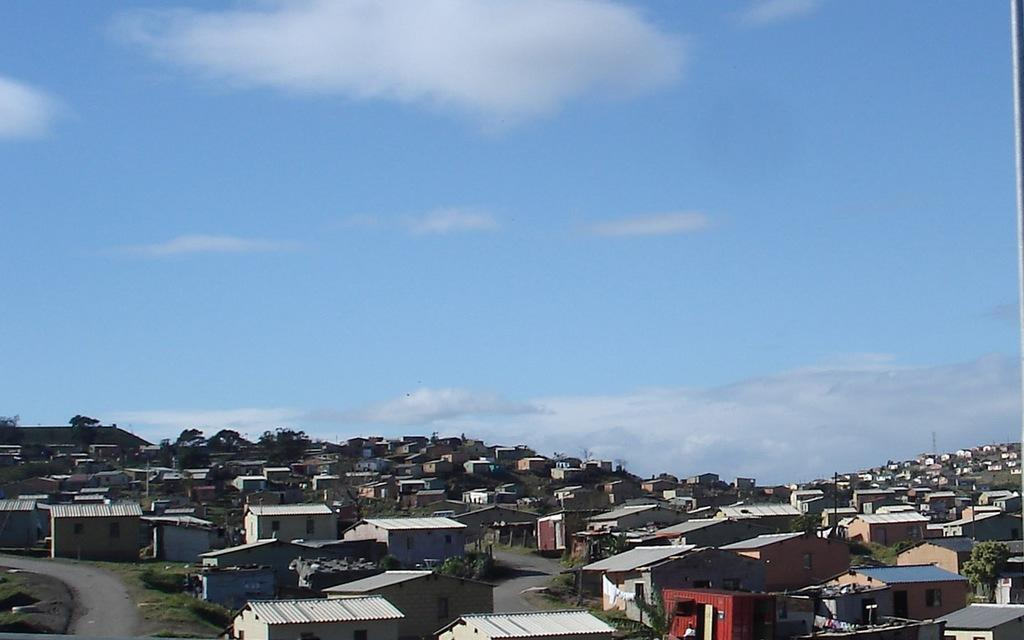What type of structures can be seen in the image? There are houses in the image. What other natural elements are present in the image? There are trees in the image. What man-made objects can be seen in the image? There are poles and roads in the image. What is visible in the sky at the top of the image? There are clouds visible in the sky at the top of the image. Where is the pin located in the image? There is no pin present in the image. What type of parcel can be seen being delivered in the image? There is no parcel being delivered in the image. Can you tell me how many goldfish are swimming in the image? There are no goldfish present in the image. 